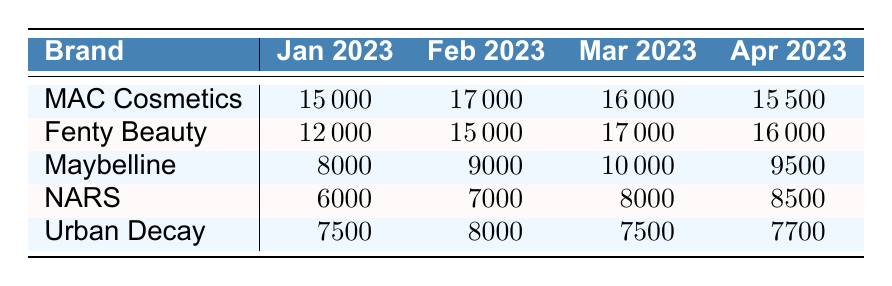What was the sales amount for Fenty Beauty in March 2023? The table shows that Fenty Beauty had sales of 17000 in March 2023.
Answer: 17000 Which brand had the highest sales in January 2023? From the table, MAC Cosmetics had the highest sales of 15000 in January 2023.
Answer: MAC Cosmetics What is the average sales amount for Maybelline across the four months? To calculate the average, sum Maybelline's sales: (8000 + 9000 + 10000 + 9500) = 38500. Divide by 4 results in 38500/4 = 9625.
Answer: 9625 Did NARS have higher sales in April 2023 than in February 2023? NARS had sales of 8500 in April and 7000 in February. Since 8500 is greater than 7000, the statement is true.
Answer: Yes In which month did Urban Decay experience the lowest sales? Urban Decay's sales were 7500 in January, 8000 in February, 7500 in March, and 7700 in April. The lowest value is 7500, which occurred in January and March.
Answer: January and March 